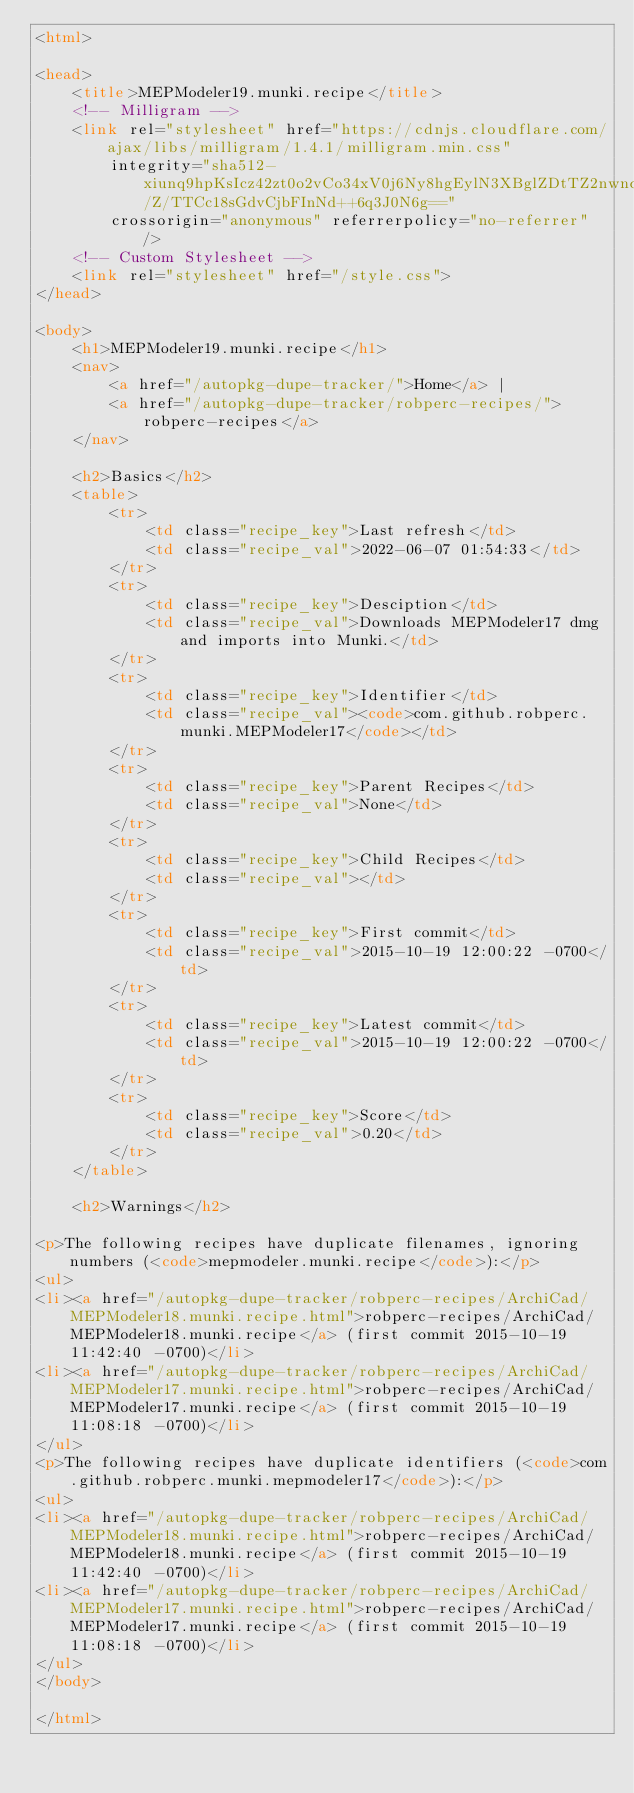<code> <loc_0><loc_0><loc_500><loc_500><_HTML_><html>

<head>
    <title>MEPModeler19.munki.recipe</title>
    <!-- Milligram -->
    <link rel="stylesheet" href="https://cdnjs.cloudflare.com/ajax/libs/milligram/1.4.1/milligram.min.css"
        integrity="sha512-xiunq9hpKsIcz42zt0o2vCo34xV0j6Ny8hgEylN3XBglZDtTZ2nwnqF/Z/TTCc18sGdvCjbFInNd++6q3J0N6g=="
        crossorigin="anonymous" referrerpolicy="no-referrer" />
    <!-- Custom Stylesheet -->
    <link rel="stylesheet" href="/style.css">
</head>

<body>
    <h1>MEPModeler19.munki.recipe</h1>
    <nav>
        <a href="/autopkg-dupe-tracker/">Home</a> |
        <a href="/autopkg-dupe-tracker/robperc-recipes/">robperc-recipes</a>
    </nav>

    <h2>Basics</h2>
    <table>
        <tr>
            <td class="recipe_key">Last refresh</td>
            <td class="recipe_val">2022-06-07 01:54:33</td>
        </tr>
        <tr>
            <td class="recipe_key">Desciption</td>
            <td class="recipe_val">Downloads MEPModeler17 dmg and imports into Munki.</td>
        </tr>
        <tr>
            <td class="recipe_key">Identifier</td>
            <td class="recipe_val"><code>com.github.robperc.munki.MEPModeler17</code></td>
        </tr>
        <tr>
            <td class="recipe_key">Parent Recipes</td>
            <td class="recipe_val">None</td>
        </tr>
        <tr>
            <td class="recipe_key">Child Recipes</td>
            <td class="recipe_val"></td>
        </tr>
        <tr>
            <td class="recipe_key">First commit</td>
            <td class="recipe_val">2015-10-19 12:00:22 -0700</td>
        </tr>
        <tr>
            <td class="recipe_key">Latest commit</td>
            <td class="recipe_val">2015-10-19 12:00:22 -0700</td>
        </tr>
        <tr>
            <td class="recipe_key">Score</td>
            <td class="recipe_val">0.20</td>
        </tr>
    </table>

    <h2>Warnings</h2>
    
<p>The following recipes have duplicate filenames, ignoring numbers (<code>mepmodeler.munki.recipe</code>):</p>
<ul>
<li><a href="/autopkg-dupe-tracker/robperc-recipes/ArchiCad/MEPModeler18.munki.recipe.html">robperc-recipes/ArchiCad/MEPModeler18.munki.recipe</a> (first commit 2015-10-19 11:42:40 -0700)</li>
<li><a href="/autopkg-dupe-tracker/robperc-recipes/ArchiCad/MEPModeler17.munki.recipe.html">robperc-recipes/ArchiCad/MEPModeler17.munki.recipe</a> (first commit 2015-10-19 11:08:18 -0700)</li>
</ul>
<p>The following recipes have duplicate identifiers (<code>com.github.robperc.munki.mepmodeler17</code>):</p>
<ul>
<li><a href="/autopkg-dupe-tracker/robperc-recipes/ArchiCad/MEPModeler18.munki.recipe.html">robperc-recipes/ArchiCad/MEPModeler18.munki.recipe</a> (first commit 2015-10-19 11:42:40 -0700)</li>
<li><a href="/autopkg-dupe-tracker/robperc-recipes/ArchiCad/MEPModeler17.munki.recipe.html">robperc-recipes/ArchiCad/MEPModeler17.munki.recipe</a> (first commit 2015-10-19 11:08:18 -0700)</li>
</ul>
</body>

</html>
</code> 